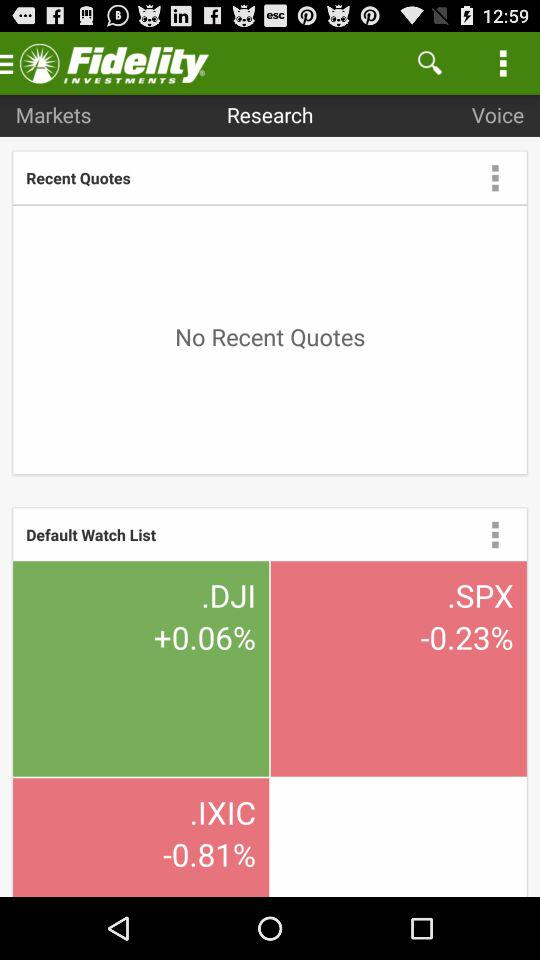What is the percentage change in.DJI? The percentage change in.DJI is +0.06. 